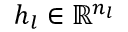Convert formula to latex. <formula><loc_0><loc_0><loc_500><loc_500>h _ { l } \in \mathbb { R } ^ { n _ { l } }</formula> 